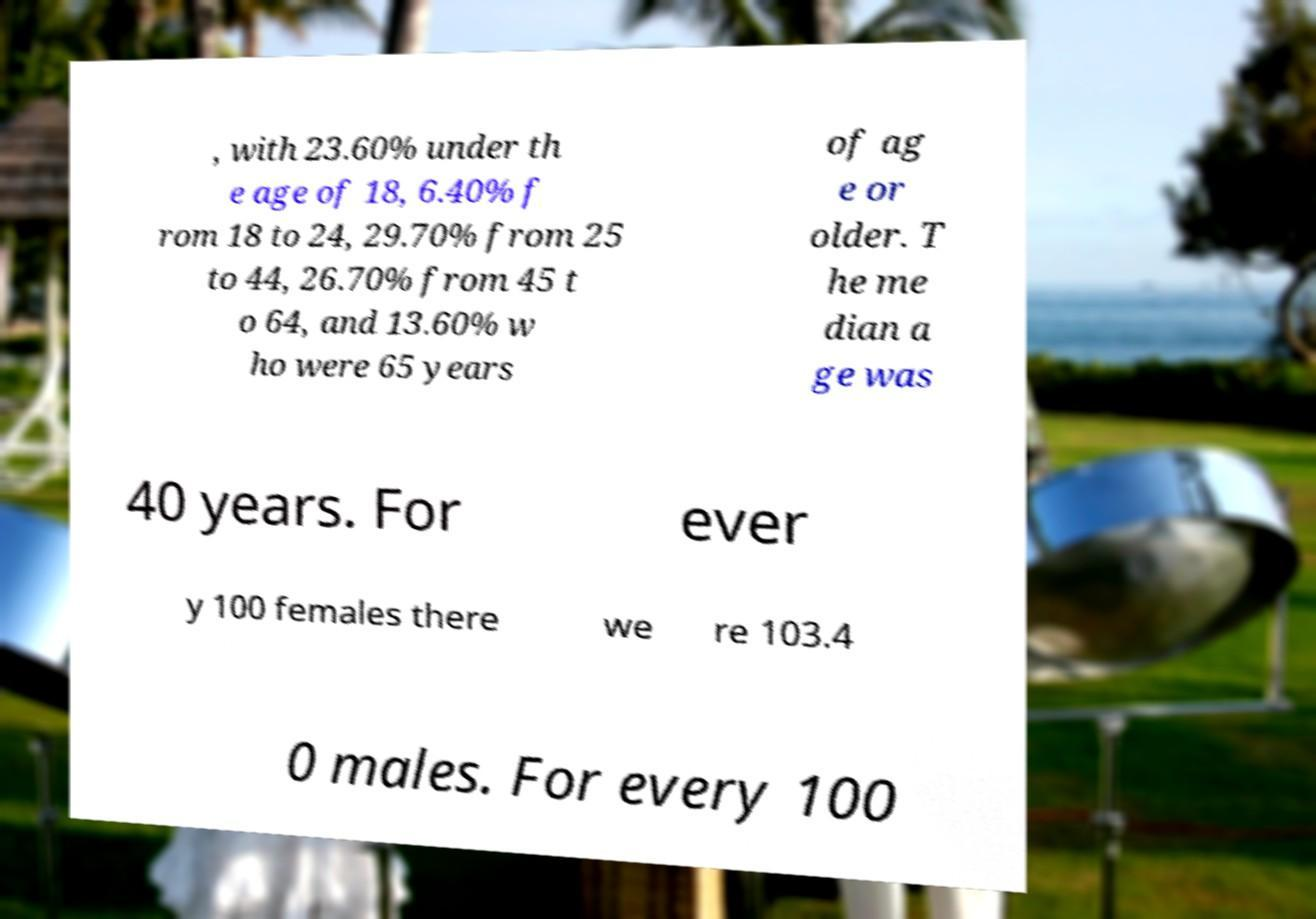Please read and relay the text visible in this image. What does it say? , with 23.60% under th e age of 18, 6.40% f rom 18 to 24, 29.70% from 25 to 44, 26.70% from 45 t o 64, and 13.60% w ho were 65 years of ag e or older. T he me dian a ge was 40 years. For ever y 100 females there we re 103.4 0 males. For every 100 